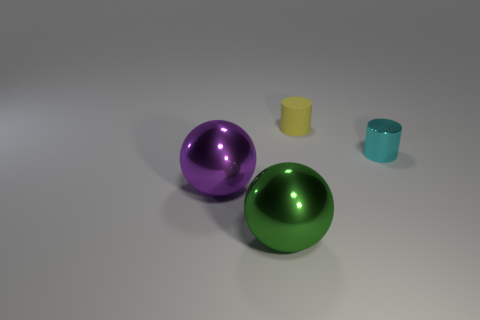There is a cylinder to the left of the tiny cyan cylinder; is there a purple shiny sphere to the left of it?
Provide a succinct answer. Yes. The big metal object in front of the purple shiny object has what shape?
Your response must be concise. Sphere. How many cyan metallic objects are in front of the thing that is behind the object on the right side of the matte object?
Your answer should be very brief. 1. There is a purple metal thing; is it the same size as the green ball that is on the left side of the cyan object?
Provide a succinct answer. Yes. How big is the yellow matte cylinder behind the big ball on the left side of the green ball?
Provide a succinct answer. Small. What number of purple balls are made of the same material as the small yellow object?
Your answer should be compact. 0. Are there any green things?
Provide a short and direct response. Yes. There is a metal sphere on the right side of the large purple sphere; what size is it?
Keep it short and to the point. Large. What number of cylinders are big green objects or large purple objects?
Your response must be concise. 0. There is a object that is behind the big green metal object and to the left of the tiny matte cylinder; what is its shape?
Offer a terse response. Sphere. 